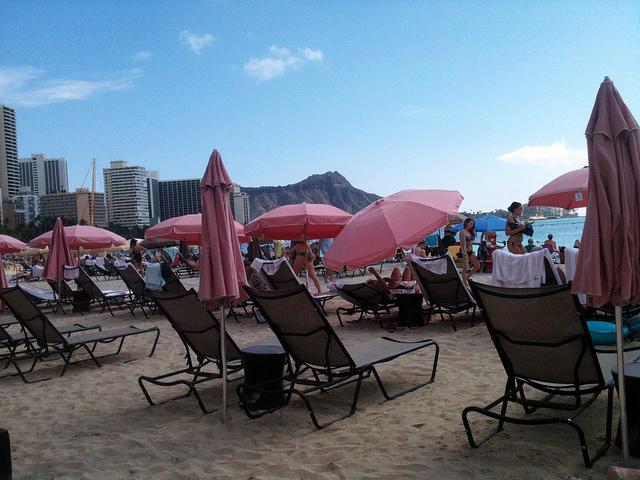What season do you think this is?
Give a very brief answer. Summer. Why are the umbrellas closed?
Be succinct. No one is sitting. What is brown on the ground?
Quick response, please. Sand. 